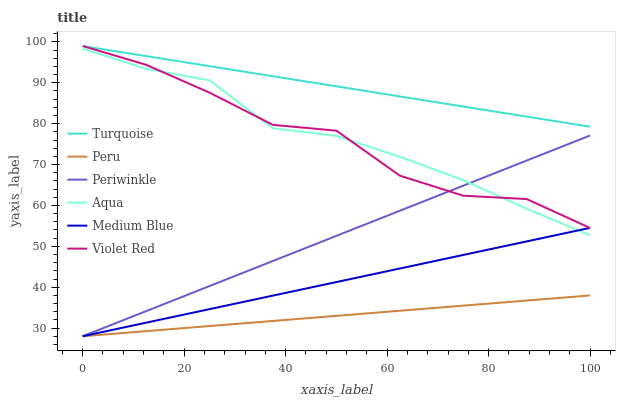Does Peru have the minimum area under the curve?
Answer yes or no. Yes. Does Turquoise have the maximum area under the curve?
Answer yes or no. Yes. Does Medium Blue have the minimum area under the curve?
Answer yes or no. No. Does Medium Blue have the maximum area under the curve?
Answer yes or no. No. Is Periwinkle the smoothest?
Answer yes or no. Yes. Is Violet Red the roughest?
Answer yes or no. Yes. Is Medium Blue the smoothest?
Answer yes or no. No. Is Medium Blue the roughest?
Answer yes or no. No. Does Medium Blue have the lowest value?
Answer yes or no. Yes. Does Aqua have the lowest value?
Answer yes or no. No. Does Violet Red have the highest value?
Answer yes or no. Yes. Does Medium Blue have the highest value?
Answer yes or no. No. Is Peru less than Aqua?
Answer yes or no. Yes. Is Turquoise greater than Aqua?
Answer yes or no. Yes. Does Turquoise intersect Violet Red?
Answer yes or no. Yes. Is Turquoise less than Violet Red?
Answer yes or no. No. Is Turquoise greater than Violet Red?
Answer yes or no. No. Does Peru intersect Aqua?
Answer yes or no. No. 